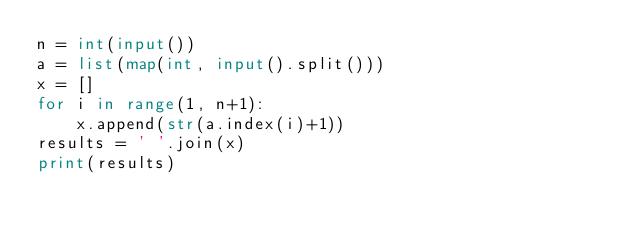Convert code to text. <code><loc_0><loc_0><loc_500><loc_500><_Python_>n = int(input())
a = list(map(int, input().split()))
x = []
for i in range(1, n+1):
    x.append(str(a.index(i)+1))
results = ' '.join(x)
print(results)</code> 